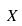<formula> <loc_0><loc_0><loc_500><loc_500>X</formula> 